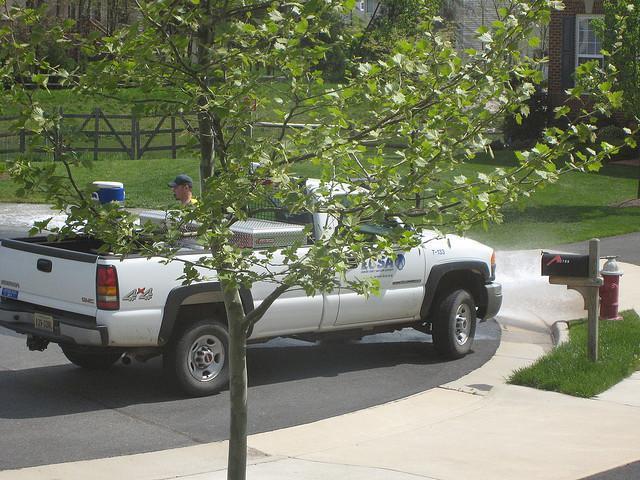What does he do?
Choose the correct response and explain in the format: 'Answer: answer
Rationale: rationale.'
Options: Parks vehicles, cleans trucks, haircuts, landscaping. Answer: landscaping.
Rationale: The name of the company is on the side of the truck. 